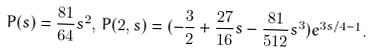<formula> <loc_0><loc_0><loc_500><loc_500>P ( s ) = \frac { 8 1 } { 6 4 } s ^ { 2 } , \, P ( 2 , s ) = ( - \frac { 3 } { 2 } + \frac { 2 7 } { 1 6 } s - \frac { 8 1 } { 5 1 2 } s ^ { 3 } ) e ^ { 3 s / 4 - 1 } .</formula> 